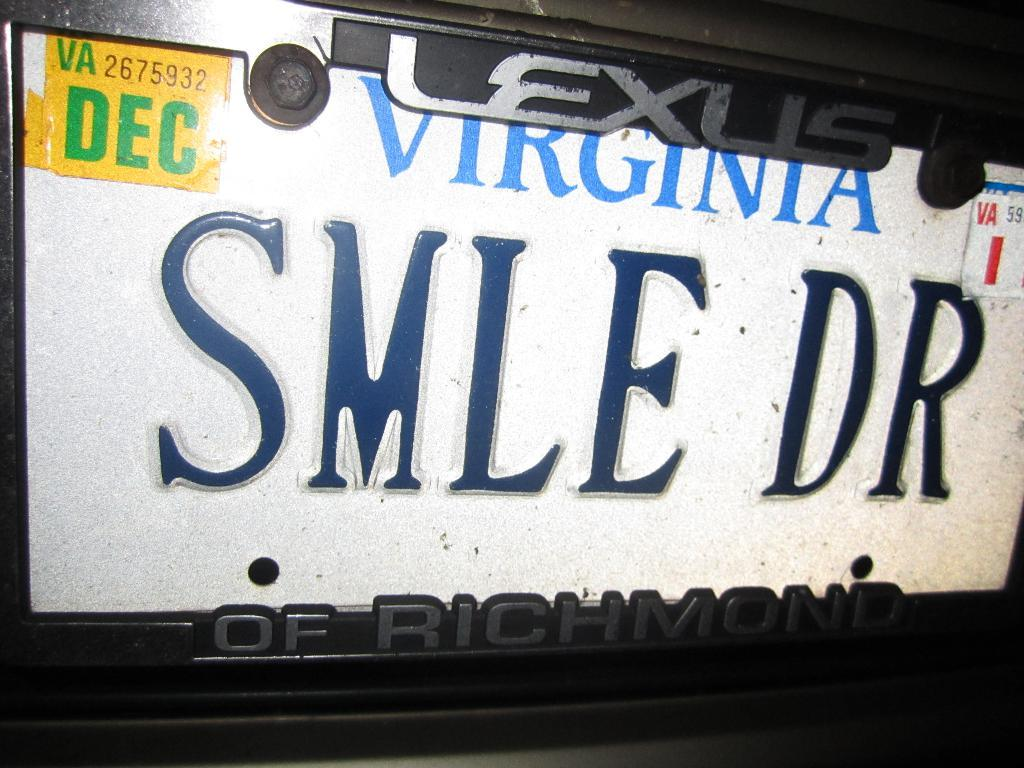What is the main object in the image? There is a name board in the image. What can be seen on the name board? The name board has some text on it. How many ants are crawling on the name board in the image? There are no ants present on the name board in the image. What type of nail is used to hang the name board in the image? There is no information about nails or how the name board is hung in the image. 